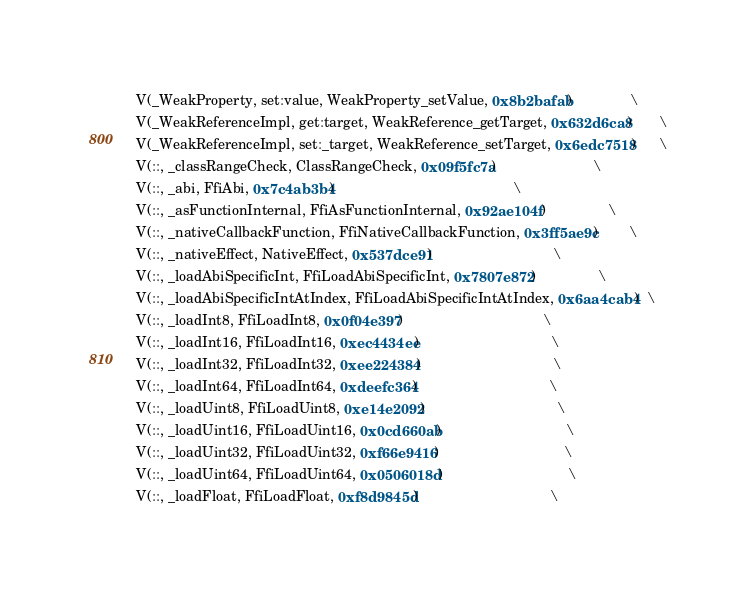Convert code to text. <code><loc_0><loc_0><loc_500><loc_500><_C_>  V(_WeakProperty, set:value, WeakProperty_setValue, 0x8b2bafab)               \
  V(_WeakReferenceImpl, get:target, WeakReference_getTarget, 0x632d6ca8)       \
  V(_WeakReferenceImpl, set:_target, WeakReference_setTarget, 0x6edc7518)      \
  V(::, _classRangeCheck, ClassRangeCheck, 0x09f5fc7a)                         \
  V(::, _abi, FfiAbi, 0x7c4ab3b4)                                              \
  V(::, _asFunctionInternal, FfiAsFunctionInternal, 0x92ae104f)                \
  V(::, _nativeCallbackFunction, FfiNativeCallbackFunction, 0x3ff5ae9c)        \
  V(::, _nativeEffect, NativeEffect, 0x537dce91)                               \
  V(::, _loadAbiSpecificInt, FfiLoadAbiSpecificInt, 0x7807e872)                \
  V(::, _loadAbiSpecificIntAtIndex, FfiLoadAbiSpecificIntAtIndex, 0x6aa4cab4)  \
  V(::, _loadInt8, FfiLoadInt8, 0x0f04e397)                                    \
  V(::, _loadInt16, FfiLoadInt16, 0xec4434ee)                                  \
  V(::, _loadInt32, FfiLoadInt32, 0xee224384)                                  \
  V(::, _loadInt64, FfiLoadInt64, 0xdeefc364)                                  \
  V(::, _loadUint8, FfiLoadUint8, 0xe14e2092)                                  \
  V(::, _loadUint16, FfiLoadUint16, 0x0cd660ab)                                \
  V(::, _loadUint32, FfiLoadUint32, 0xf66e9416)                                \
  V(::, _loadUint64, FfiLoadUint64, 0x0506018d)                                \
  V(::, _loadFloat, FfiLoadFloat, 0xf8d9845d)                                  \</code> 